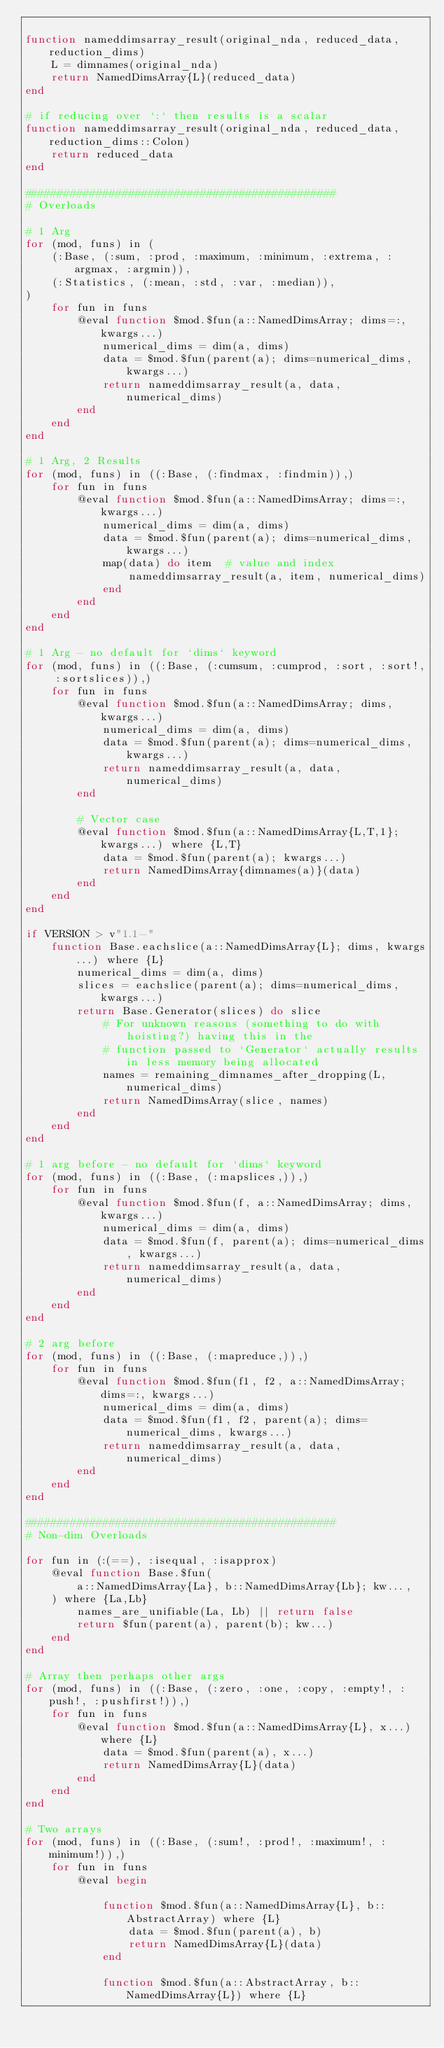<code> <loc_0><loc_0><loc_500><loc_500><_Julia_>
function nameddimsarray_result(original_nda, reduced_data, reduction_dims)
    L = dimnames(original_nda)
    return NamedDimsArray{L}(reduced_data)
end

# if reducing over `:` then results is a scalar
function nameddimsarray_result(original_nda, reduced_data, reduction_dims::Colon)
    return reduced_data
end

################################################
# Overloads

# 1 Arg
for (mod, funs) in (
    (:Base, (:sum, :prod, :maximum, :minimum, :extrema, :argmax, :argmin)),
    (:Statistics, (:mean, :std, :var, :median)),
)
    for fun in funs
        @eval function $mod.$fun(a::NamedDimsArray; dims=:, kwargs...)
            numerical_dims = dim(a, dims)
            data = $mod.$fun(parent(a); dims=numerical_dims, kwargs...)
            return nameddimsarray_result(a, data, numerical_dims)
        end
    end
end

# 1 Arg, 2 Results
for (mod, funs) in ((:Base, (:findmax, :findmin)),)
    for fun in funs
        @eval function $mod.$fun(a::NamedDimsArray; dims=:, kwargs...)
            numerical_dims = dim(a, dims)
            data = $mod.$fun(parent(a); dims=numerical_dims, kwargs...)
            map(data) do item  # value and index
                nameddimsarray_result(a, item, numerical_dims)
            end
        end
    end
end

# 1 Arg - no default for `dims` keyword
for (mod, funs) in ((:Base, (:cumsum, :cumprod, :sort, :sort!, :sortslices)),)
    for fun in funs
        @eval function $mod.$fun(a::NamedDimsArray; dims, kwargs...)
            numerical_dims = dim(a, dims)
            data = $mod.$fun(parent(a); dims=numerical_dims, kwargs...)
            return nameddimsarray_result(a, data, numerical_dims)
        end

        # Vector case
        @eval function $mod.$fun(a::NamedDimsArray{L,T,1}; kwargs...) where {L,T}
            data = $mod.$fun(parent(a); kwargs...)
            return NamedDimsArray{dimnames(a)}(data)
        end
    end
end

if VERSION > v"1.1-"
    function Base.eachslice(a::NamedDimsArray{L}; dims, kwargs...) where {L}
        numerical_dims = dim(a, dims)
        slices = eachslice(parent(a); dims=numerical_dims, kwargs...)
        return Base.Generator(slices) do slice
            # For unknown reasons (something to do with hoisting?) having this in the
            # function passed to `Generator` actually results in less memory being allocated
            names = remaining_dimnames_after_dropping(L, numerical_dims)
            return NamedDimsArray(slice, names)
        end
    end
end

# 1 arg before - no default for `dims` keyword
for (mod, funs) in ((:Base, (:mapslices,)),)
    for fun in funs
        @eval function $mod.$fun(f, a::NamedDimsArray; dims, kwargs...)
            numerical_dims = dim(a, dims)
            data = $mod.$fun(f, parent(a); dims=numerical_dims, kwargs...)
            return nameddimsarray_result(a, data, numerical_dims)
        end
    end
end

# 2 arg before
for (mod, funs) in ((:Base, (:mapreduce,)),)
    for fun in funs
        @eval function $mod.$fun(f1, f2, a::NamedDimsArray; dims=:, kwargs...)
            numerical_dims = dim(a, dims)
            data = $mod.$fun(f1, f2, parent(a); dims=numerical_dims, kwargs...)
            return nameddimsarray_result(a, data, numerical_dims)
        end
    end
end

################################################
# Non-dim Overloads

for fun in (:(==), :isequal, :isapprox)
    @eval function Base.$fun(
        a::NamedDimsArray{La}, b::NamedDimsArray{Lb}; kw...,
    ) where {La,Lb}
        names_are_unifiable(La, Lb) || return false
        return $fun(parent(a), parent(b); kw...)
    end
end

# Array then perhaps other args
for (mod, funs) in ((:Base, (:zero, :one, :copy, :empty!, :push!, :pushfirst!)),)
    for fun in funs
        @eval function $mod.$fun(a::NamedDimsArray{L}, x...) where {L}
            data = $mod.$fun(parent(a), x...)
            return NamedDimsArray{L}(data)
        end
    end
end

# Two arrays
for (mod, funs) in ((:Base, (:sum!, :prod!, :maximum!, :minimum!)),)
    for fun in funs
        @eval begin

            function $mod.$fun(a::NamedDimsArray{L}, b::AbstractArray) where {L}
                data = $mod.$fun(parent(a), b)
                return NamedDimsArray{L}(data)
            end

            function $mod.$fun(a::AbstractArray, b::NamedDimsArray{L}) where {L}</code> 